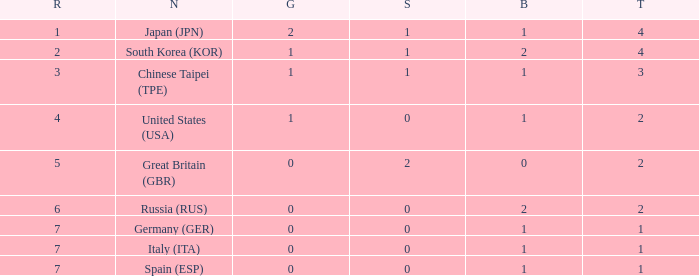How many total medals does a country with more than 1 silver medals have? 2.0. 